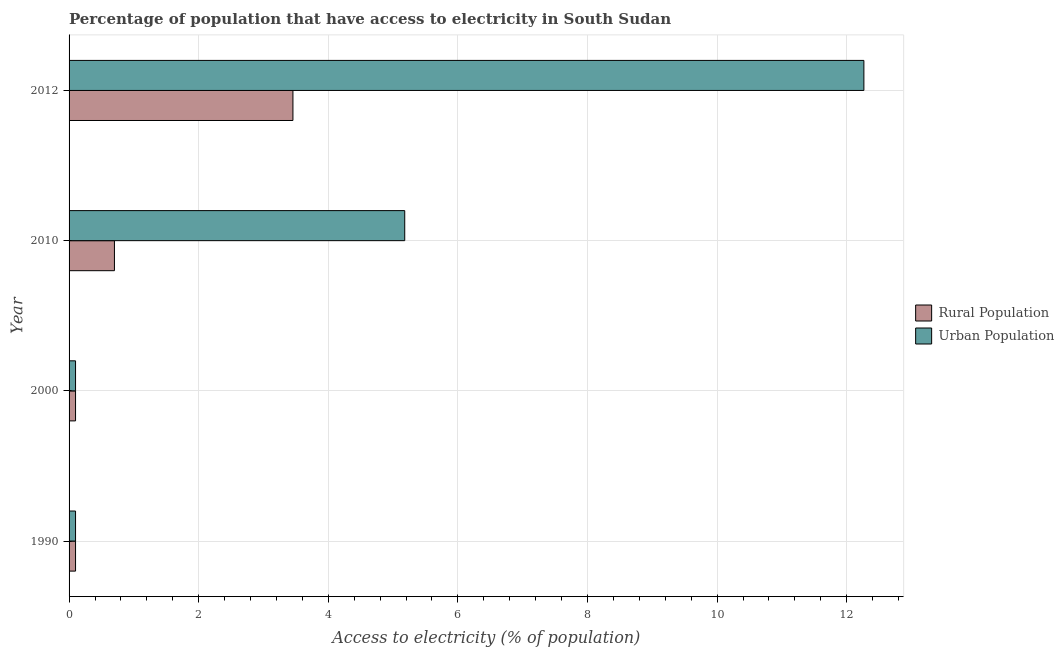Are the number of bars per tick equal to the number of legend labels?
Your answer should be very brief. Yes. Are the number of bars on each tick of the Y-axis equal?
Your answer should be compact. Yes. How many bars are there on the 3rd tick from the top?
Provide a succinct answer. 2. How many bars are there on the 2nd tick from the bottom?
Provide a succinct answer. 2. In how many cases, is the number of bars for a given year not equal to the number of legend labels?
Your answer should be compact. 0. Across all years, what is the maximum percentage of rural population having access to electricity?
Offer a very short reply. 3.45. Across all years, what is the minimum percentage of rural population having access to electricity?
Offer a very short reply. 0.1. In which year was the percentage of rural population having access to electricity minimum?
Give a very brief answer. 1990. What is the total percentage of rural population having access to electricity in the graph?
Provide a succinct answer. 4.35. What is the difference between the percentage of urban population having access to electricity in 2012 and the percentage of rural population having access to electricity in 1990?
Provide a succinct answer. 12.17. What is the average percentage of rural population having access to electricity per year?
Provide a succinct answer. 1.09. In the year 2010, what is the difference between the percentage of rural population having access to electricity and percentage of urban population having access to electricity?
Your response must be concise. -4.48. What is the difference between the highest and the second highest percentage of urban population having access to electricity?
Give a very brief answer. 7.08. What is the difference between the highest and the lowest percentage of urban population having access to electricity?
Make the answer very short. 12.17. What does the 2nd bar from the top in 2010 represents?
Your answer should be compact. Rural Population. What does the 2nd bar from the bottom in 1990 represents?
Offer a terse response. Urban Population. How many bars are there?
Your answer should be compact. 8. How many years are there in the graph?
Offer a terse response. 4. Are the values on the major ticks of X-axis written in scientific E-notation?
Keep it short and to the point. No. Does the graph contain grids?
Provide a short and direct response. Yes. Where does the legend appear in the graph?
Your answer should be very brief. Center right. How many legend labels are there?
Offer a terse response. 2. How are the legend labels stacked?
Provide a succinct answer. Vertical. What is the title of the graph?
Keep it short and to the point. Percentage of population that have access to electricity in South Sudan. What is the label or title of the X-axis?
Your answer should be very brief. Access to electricity (% of population). What is the Access to electricity (% of population) in Rural Population in 1990?
Ensure brevity in your answer.  0.1. What is the Access to electricity (% of population) of Urban Population in 1990?
Your answer should be compact. 0.1. What is the Access to electricity (% of population) in Rural Population in 2000?
Offer a terse response. 0.1. What is the Access to electricity (% of population) of Urban Population in 2000?
Your answer should be compact. 0.1. What is the Access to electricity (% of population) in Urban Population in 2010?
Your answer should be compact. 5.18. What is the Access to electricity (% of population) in Rural Population in 2012?
Provide a succinct answer. 3.45. What is the Access to electricity (% of population) of Urban Population in 2012?
Your response must be concise. 12.27. Across all years, what is the maximum Access to electricity (% of population) in Rural Population?
Offer a very short reply. 3.45. Across all years, what is the maximum Access to electricity (% of population) in Urban Population?
Ensure brevity in your answer.  12.27. Across all years, what is the minimum Access to electricity (% of population) in Urban Population?
Your answer should be very brief. 0.1. What is the total Access to electricity (% of population) of Rural Population in the graph?
Offer a terse response. 4.35. What is the total Access to electricity (% of population) in Urban Population in the graph?
Give a very brief answer. 17.64. What is the difference between the Access to electricity (% of population) of Urban Population in 1990 and that in 2000?
Provide a succinct answer. 0. What is the difference between the Access to electricity (% of population) of Rural Population in 1990 and that in 2010?
Your response must be concise. -0.6. What is the difference between the Access to electricity (% of population) in Urban Population in 1990 and that in 2010?
Offer a very short reply. -5.08. What is the difference between the Access to electricity (% of population) of Rural Population in 1990 and that in 2012?
Keep it short and to the point. -3.35. What is the difference between the Access to electricity (% of population) in Urban Population in 1990 and that in 2012?
Your answer should be very brief. -12.17. What is the difference between the Access to electricity (% of population) in Rural Population in 2000 and that in 2010?
Make the answer very short. -0.6. What is the difference between the Access to electricity (% of population) of Urban Population in 2000 and that in 2010?
Offer a terse response. -5.08. What is the difference between the Access to electricity (% of population) of Rural Population in 2000 and that in 2012?
Your answer should be compact. -3.35. What is the difference between the Access to electricity (% of population) in Urban Population in 2000 and that in 2012?
Provide a succinct answer. -12.17. What is the difference between the Access to electricity (% of population) in Rural Population in 2010 and that in 2012?
Offer a terse response. -2.75. What is the difference between the Access to electricity (% of population) of Urban Population in 2010 and that in 2012?
Provide a short and direct response. -7.09. What is the difference between the Access to electricity (% of population) of Rural Population in 1990 and the Access to electricity (% of population) of Urban Population in 2010?
Provide a succinct answer. -5.08. What is the difference between the Access to electricity (% of population) of Rural Population in 1990 and the Access to electricity (% of population) of Urban Population in 2012?
Provide a succinct answer. -12.17. What is the difference between the Access to electricity (% of population) of Rural Population in 2000 and the Access to electricity (% of population) of Urban Population in 2010?
Keep it short and to the point. -5.08. What is the difference between the Access to electricity (% of population) in Rural Population in 2000 and the Access to electricity (% of population) in Urban Population in 2012?
Offer a very short reply. -12.17. What is the difference between the Access to electricity (% of population) in Rural Population in 2010 and the Access to electricity (% of population) in Urban Population in 2012?
Your response must be concise. -11.57. What is the average Access to electricity (% of population) of Rural Population per year?
Keep it short and to the point. 1.09. What is the average Access to electricity (% of population) of Urban Population per year?
Provide a succinct answer. 4.41. In the year 2010, what is the difference between the Access to electricity (% of population) in Rural Population and Access to electricity (% of population) in Urban Population?
Make the answer very short. -4.48. In the year 2012, what is the difference between the Access to electricity (% of population) of Rural Population and Access to electricity (% of population) of Urban Population?
Provide a short and direct response. -8.81. What is the ratio of the Access to electricity (% of population) in Rural Population in 1990 to that in 2000?
Your answer should be very brief. 1. What is the ratio of the Access to electricity (% of population) of Rural Population in 1990 to that in 2010?
Your answer should be compact. 0.14. What is the ratio of the Access to electricity (% of population) in Urban Population in 1990 to that in 2010?
Give a very brief answer. 0.02. What is the ratio of the Access to electricity (% of population) in Rural Population in 1990 to that in 2012?
Your answer should be compact. 0.03. What is the ratio of the Access to electricity (% of population) of Urban Population in 1990 to that in 2012?
Your answer should be compact. 0.01. What is the ratio of the Access to electricity (% of population) of Rural Population in 2000 to that in 2010?
Your answer should be compact. 0.14. What is the ratio of the Access to electricity (% of population) of Urban Population in 2000 to that in 2010?
Keep it short and to the point. 0.02. What is the ratio of the Access to electricity (% of population) of Rural Population in 2000 to that in 2012?
Keep it short and to the point. 0.03. What is the ratio of the Access to electricity (% of population) of Urban Population in 2000 to that in 2012?
Your answer should be compact. 0.01. What is the ratio of the Access to electricity (% of population) in Rural Population in 2010 to that in 2012?
Ensure brevity in your answer.  0.2. What is the ratio of the Access to electricity (% of population) of Urban Population in 2010 to that in 2012?
Provide a short and direct response. 0.42. What is the difference between the highest and the second highest Access to electricity (% of population) of Rural Population?
Make the answer very short. 2.75. What is the difference between the highest and the second highest Access to electricity (% of population) of Urban Population?
Offer a terse response. 7.09. What is the difference between the highest and the lowest Access to electricity (% of population) in Rural Population?
Provide a succinct answer. 3.35. What is the difference between the highest and the lowest Access to electricity (% of population) in Urban Population?
Give a very brief answer. 12.17. 